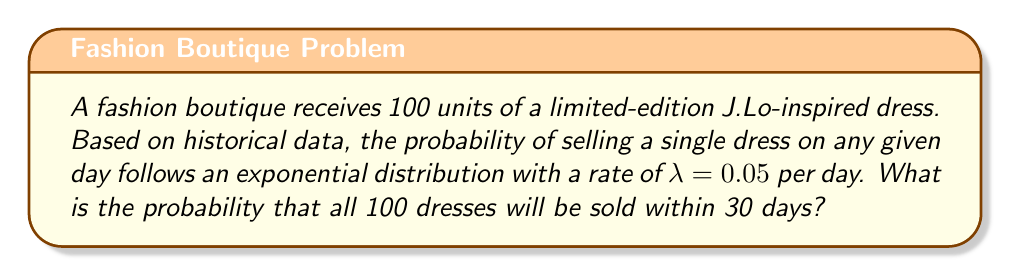Can you answer this question? Let's approach this step-by-step:

1) The probability of selling a single dress within time $t$ is given by the cumulative distribution function of the exponential distribution:

   $F(t) = 1 - e^{-\lambda t}$

2) For our case, $\lambda = 0.05$ and $t = 30$, so the probability of selling one dress within 30 days is:

   $F(30) = 1 - e^{-0.05 \times 30} = 1 - e^{-1.5} \approx 0.7769$

3) Now, we need all 100 dresses to be sold. This is equivalent to the probability of the minimum of 100 exponential random variables being less than or equal to 30.

4) The minimum of $n$ independent exponential random variables with rate $\lambda$ is exponentially distributed with rate $n\lambda$.

5) In our case, $n = 100$ and $\lambda = 0.05$, so the rate for the minimum is $100 \times 0.05 = 5$.

6) Therefore, the probability of all 100 dresses being sold within 30 days is:

   $P(\text{all sold in 30 days}) = 1 - e^{-5 \times 30} = 1 - e^{-150}$

7) Calculating this:

   $1 - e^{-150} \approx 1 - 7.2661 \times 10^{-66} \approx 1$

The probability is extremely close to 1, indicating it's almost certain that all dresses will be sold within 30 days.
Answer: $1 - e^{-150} \approx 1$ 